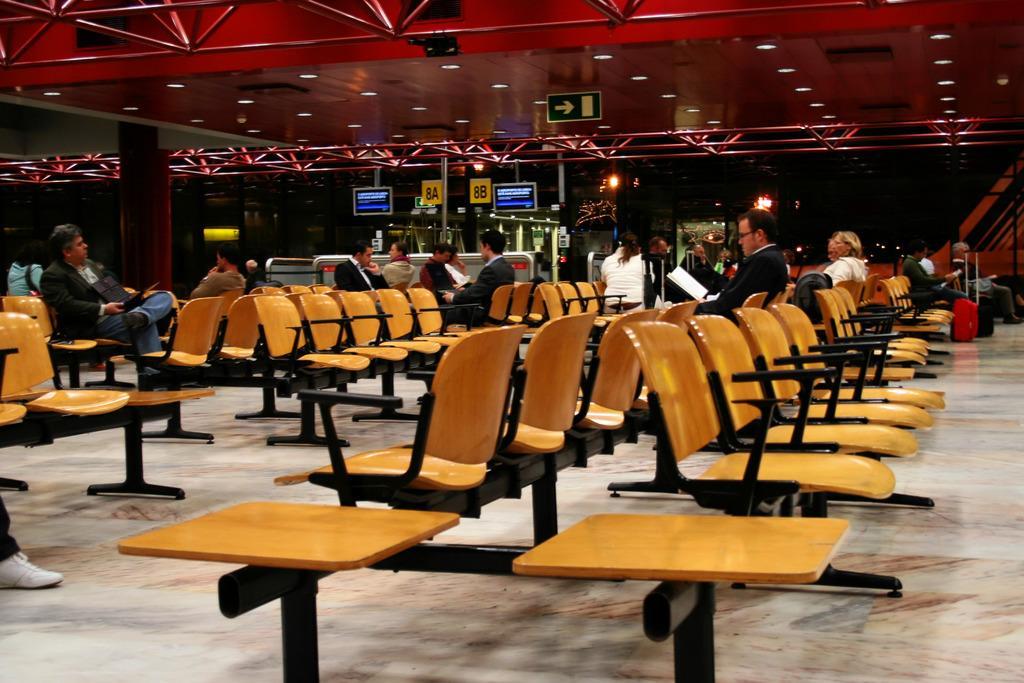Could you give a brief overview of what you see in this image? People are sitting on yellow chairs. Here we can signboard, screens and boards. There is a pillar. Background it is dark. Light are attached to the ceiling. In-front of that person there are luggages. Two people are holding laptops and one person is holding a book.  